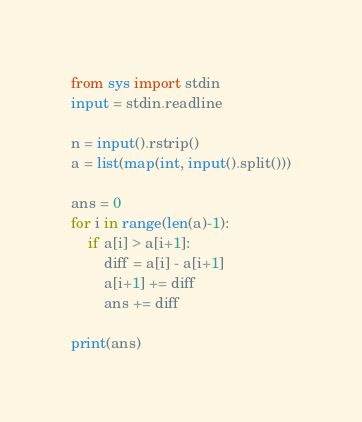<code> <loc_0><loc_0><loc_500><loc_500><_Python_>from sys import stdin
input = stdin.readline

n = input().rstrip()
a = list(map(int, input().split()))

ans = 0
for i in range(len(a)-1):
    if a[i] > a[i+1]:
        diff = a[i] - a[i+1]
        a[i+1] += diff
        ans += diff

print(ans)</code> 